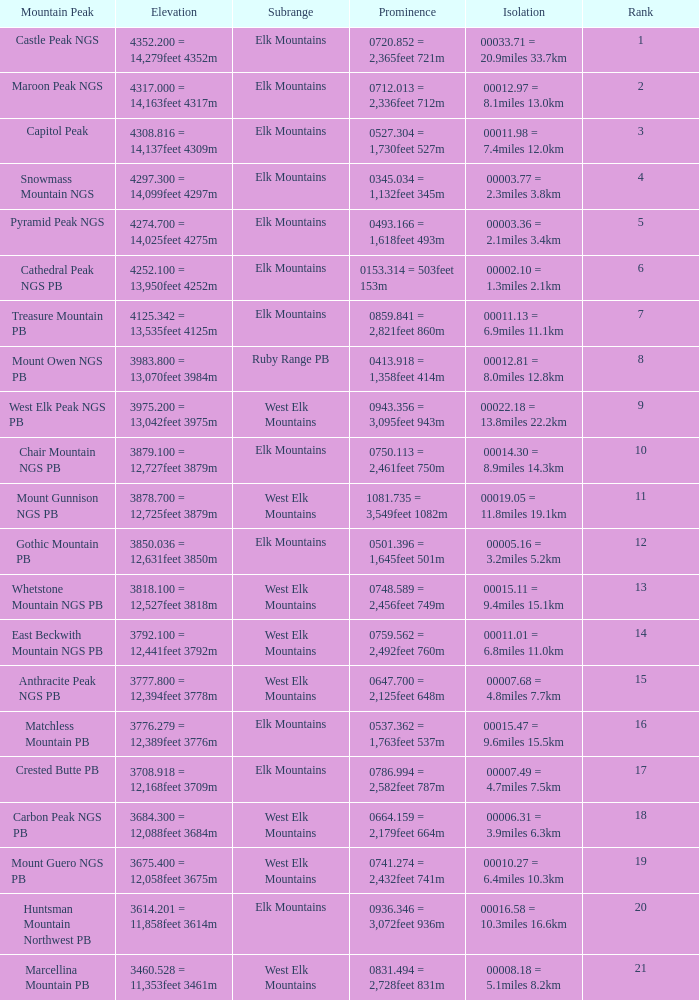Name the Rank of Rank Mountain Peak of crested butte pb? 17.0. 